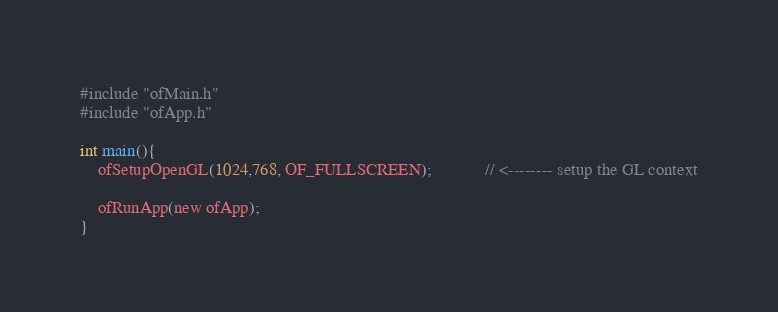<code> <loc_0><loc_0><loc_500><loc_500><_ObjectiveC_>#include "ofMain.h"
#include "ofApp.h"

int main(){
	ofSetupOpenGL(1024,768, OF_FULLSCREEN);			// <-------- setup the GL context

	ofRunApp(new ofApp);
}
</code> 